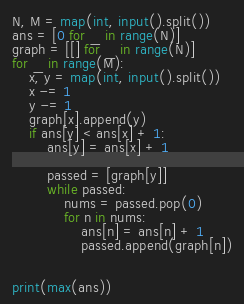Convert code to text. <code><loc_0><loc_0><loc_500><loc_500><_Python_>N, M = map(int, input().split())
ans = [0 for _ in range(N)]
graph = [[] for _ in range(N)]
for _ in range(M):
    x, y = map(int, input().split())
    x -= 1
    y -= 1
    graph[x].append(y)
    if ans[y] < ans[x] + 1:
        ans[y] = ans[x] + 1

        passed = [graph[y]]
        while passed:
            nums = passed.pop(0)
            for n in nums:
                ans[n] = ans[n] + 1
                passed.append(graph[n])


print(max(ans))</code> 